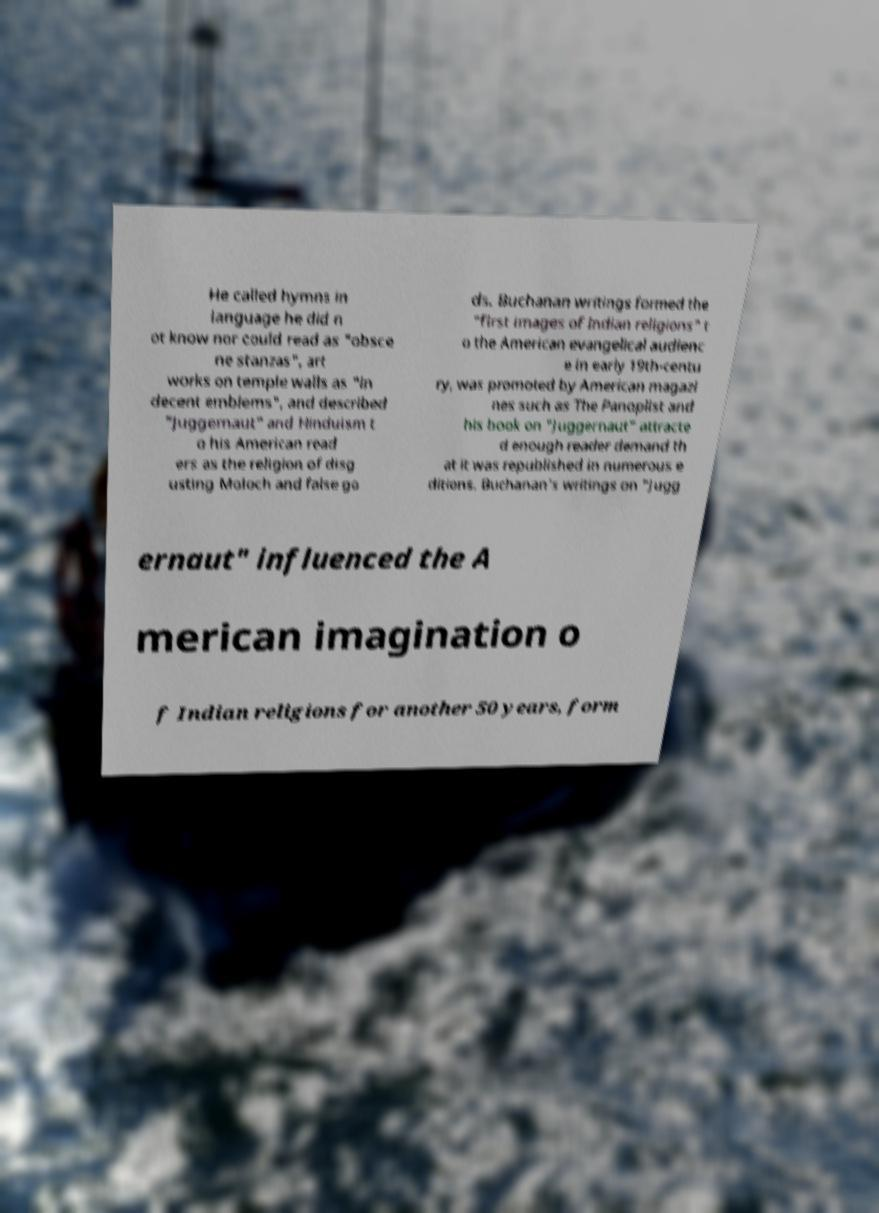Can you read and provide the text displayed in the image?This photo seems to have some interesting text. Can you extract and type it out for me? He called hymns in language he did n ot know nor could read as "obsce ne stanzas", art works on temple walls as "in decent emblems", and described "Juggernaut" and Hinduism t o his American read ers as the religion of disg usting Moloch and false go ds. Buchanan writings formed the "first images of Indian religions" t o the American evangelical audienc e in early 19th-centu ry, was promoted by American magazi nes such as The Panoplist and his book on "Juggernaut" attracte d enough reader demand th at it was republished in numerous e ditions. Buchanan's writings on "Jugg ernaut" influenced the A merican imagination o f Indian religions for another 50 years, form 